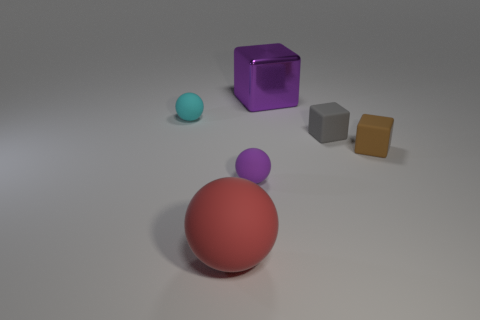Add 3 tiny brown cubes. How many objects exist? 9 Add 6 tiny gray things. How many tiny gray things are left? 7 Add 6 red things. How many red things exist? 7 Subtract 0 green blocks. How many objects are left? 6 Subtract all purple rubber balls. Subtract all brown matte cylinders. How many objects are left? 5 